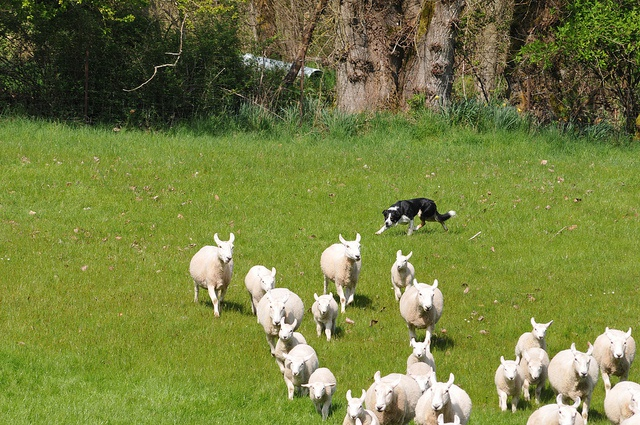Describe the objects in this image and their specific colors. I can see sheep in black, white, tan, and olive tones, sheep in black, white, tan, and gray tones, sheep in black, white, and tan tones, dog in black, gray, and olive tones, and sheep in black, white, darkgreen, and tan tones in this image. 